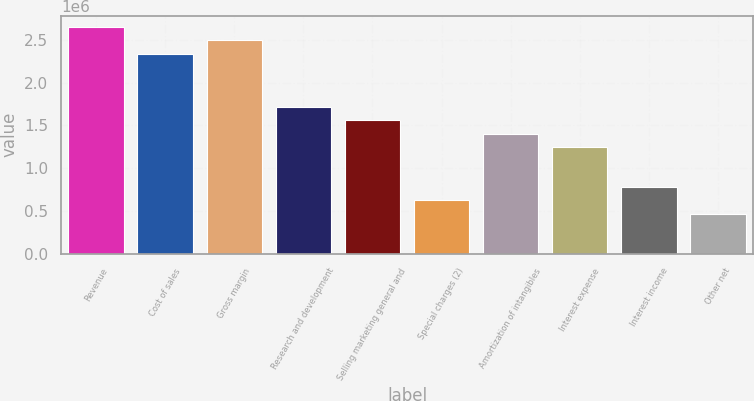<chart> <loc_0><loc_0><loc_500><loc_500><bar_chart><fcel>Revenue<fcel>Cost of sales<fcel>Gross margin<fcel>Research and development<fcel>Selling marketing general and<fcel>Special charges (2)<fcel>Amortization of intangibles<fcel>Interest expense<fcel>Interest income<fcel>Other net<nl><fcel>2.64892e+06<fcel>2.33728e+06<fcel>2.4931e+06<fcel>1.71401e+06<fcel>1.55819e+06<fcel>623276<fcel>1.40237e+06<fcel>1.24655e+06<fcel>779095<fcel>467457<nl></chart> 